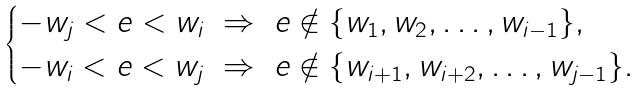Convert formula to latex. <formula><loc_0><loc_0><loc_500><loc_500>\begin{cases} - w _ { j } < e < w _ { i } \ \Rightarrow \ e \notin \{ w _ { 1 } , w _ { 2 } , \dots , w _ { i - 1 } \} , \\ - w _ { i } < e < w _ { j } \ \Rightarrow \ e \notin \{ w _ { i + 1 } , w _ { i + 2 } , \dots , w _ { j - 1 } \} . \end{cases}</formula> 